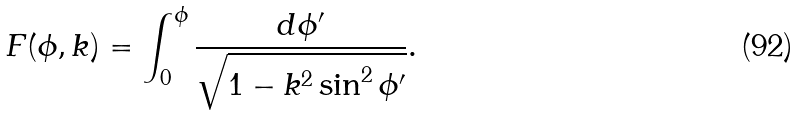Convert formula to latex. <formula><loc_0><loc_0><loc_500><loc_500>F ( \phi , k ) = \int _ { 0 } ^ { \phi } \frac { d \phi ^ { \prime } } { \sqrt { 1 - k ^ { 2 } \sin ^ { 2 } \phi ^ { \prime } } } .</formula> 